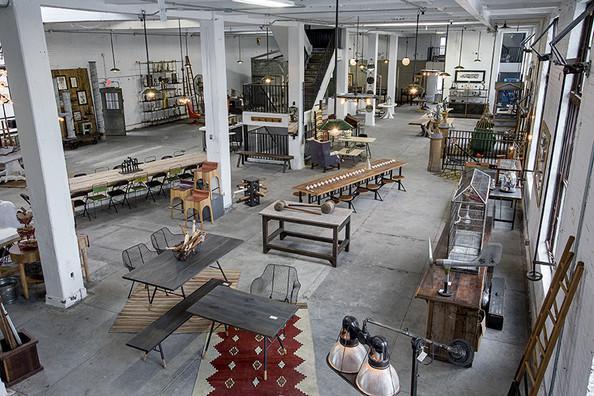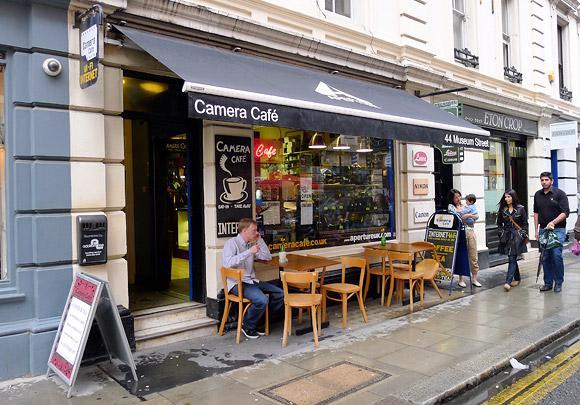The first image is the image on the left, the second image is the image on the right. Analyze the images presented: Is the assertion "An image shows the front of an eatery inside a bigger building, with signage that includes bright green color and a red fruit." valid? Answer yes or no. No. 